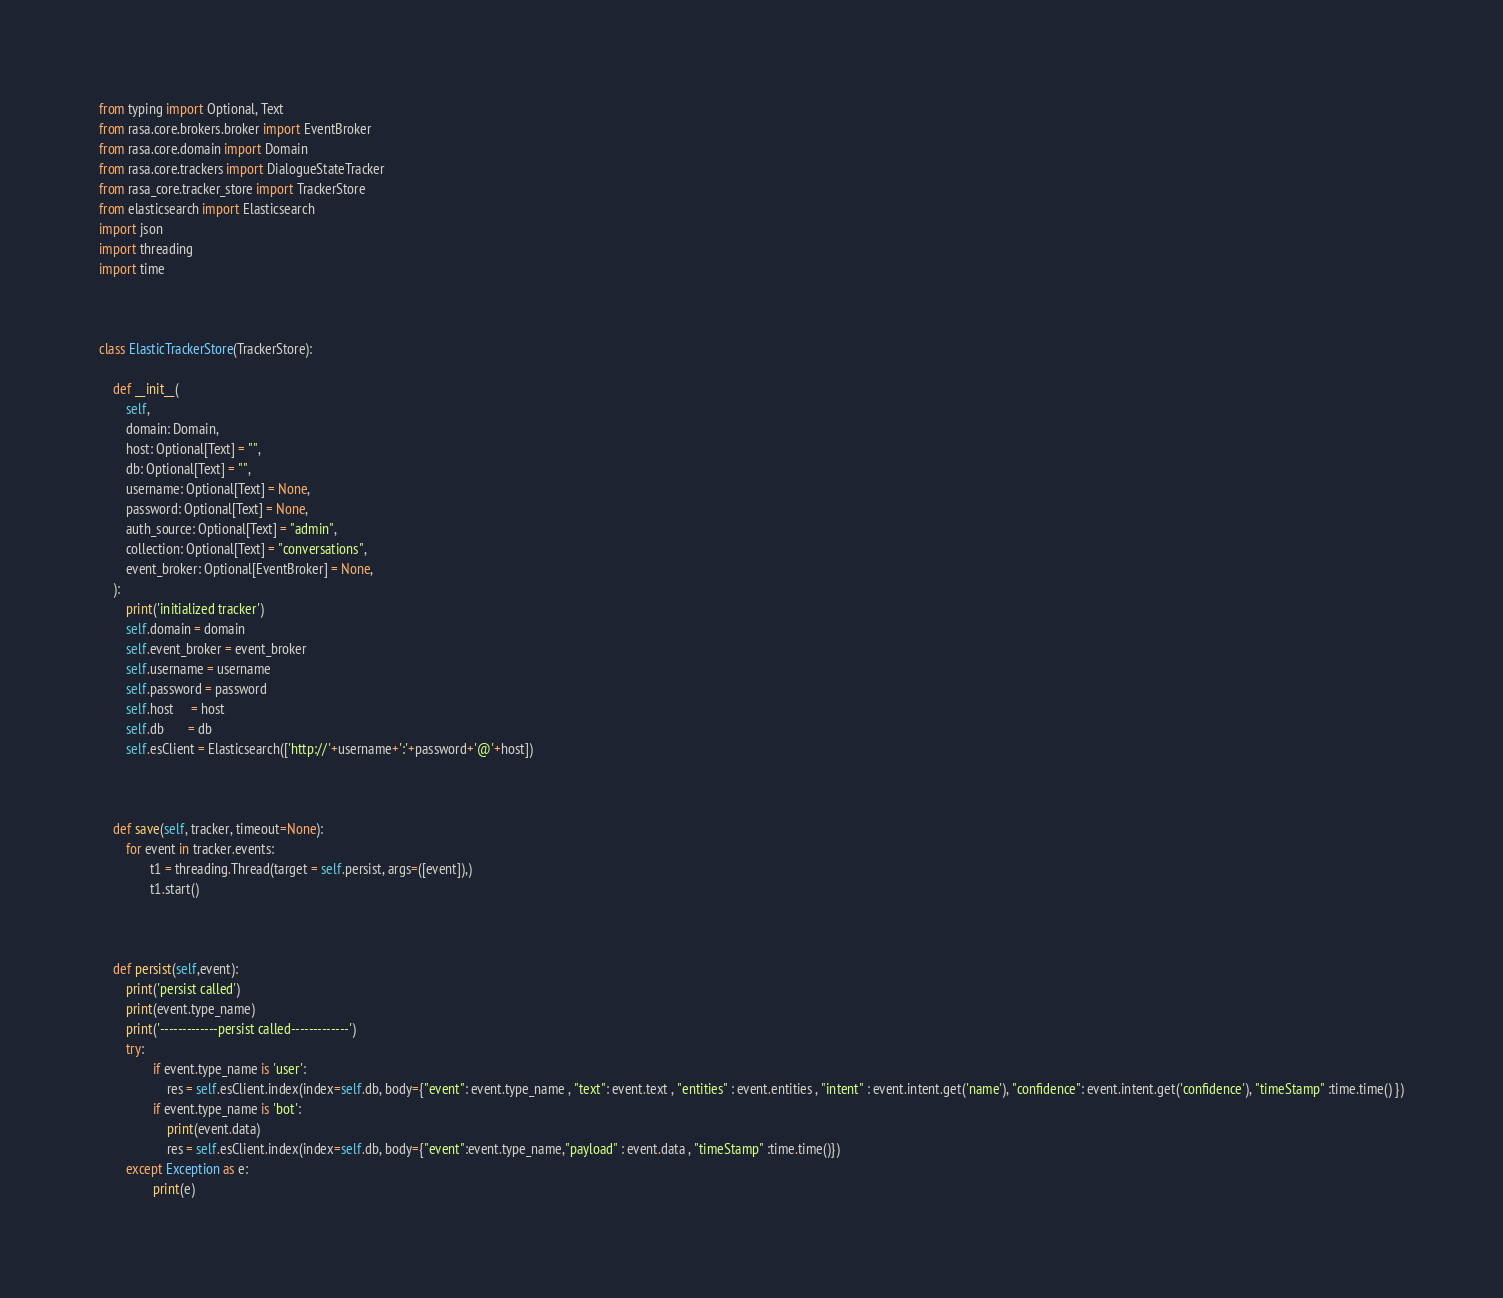<code> <loc_0><loc_0><loc_500><loc_500><_Python_>from typing import Optional, Text
from rasa.core.brokers.broker import EventBroker
from rasa.core.domain import Domain
from rasa.core.trackers import DialogueStateTracker
from rasa_core.tracker_store import TrackerStore
from elasticsearch import Elasticsearch
import json
import threading
import time



class ElasticTrackerStore(TrackerStore):

    def __init__(
        self,
        domain: Domain,
        host: Optional[Text] = "",
        db: Optional[Text] = "",
        username: Optional[Text] = None,
        password: Optional[Text] = None,
        auth_source: Optional[Text] = "admin",
        collection: Optional[Text] = "conversations",
        event_broker: Optional[EventBroker] = None,
    ):
        print('initialized tracker')
        self.domain = domain
        self.event_broker = event_broker
        self.username = username
        self.password = password
        self.host     = host
        self.db       = db
        self.esClient = Elasticsearch(['http://'+username+':'+password+'@'+host])



    def save(self, tracker, timeout=None):
        for event in tracker.events:
               t1 = threading.Thread(target = self.persist, args=([event]),)
               t1.start()



    def persist(self,event):
        print('persist called')
        print(event.type_name)
        print('-------------persist called-------------')
        try:
                if event.type_name is 'user':
                    res = self.esClient.index(index=self.db, body={"event": event.type_name , "text": event.text , "entities" : event.entities , "intent" : event.intent.get('name'), "confidence": event.intent.get('confidence'), "timeStamp" :time.time() })
                if event.type_name is 'bot':
                    print(event.data)
                    res = self.esClient.index(index=self.db, body={"event":event.type_name,"payload" : event.data , "timeStamp" :time.time()})
        except Exception as e:
                print(e)



</code> 